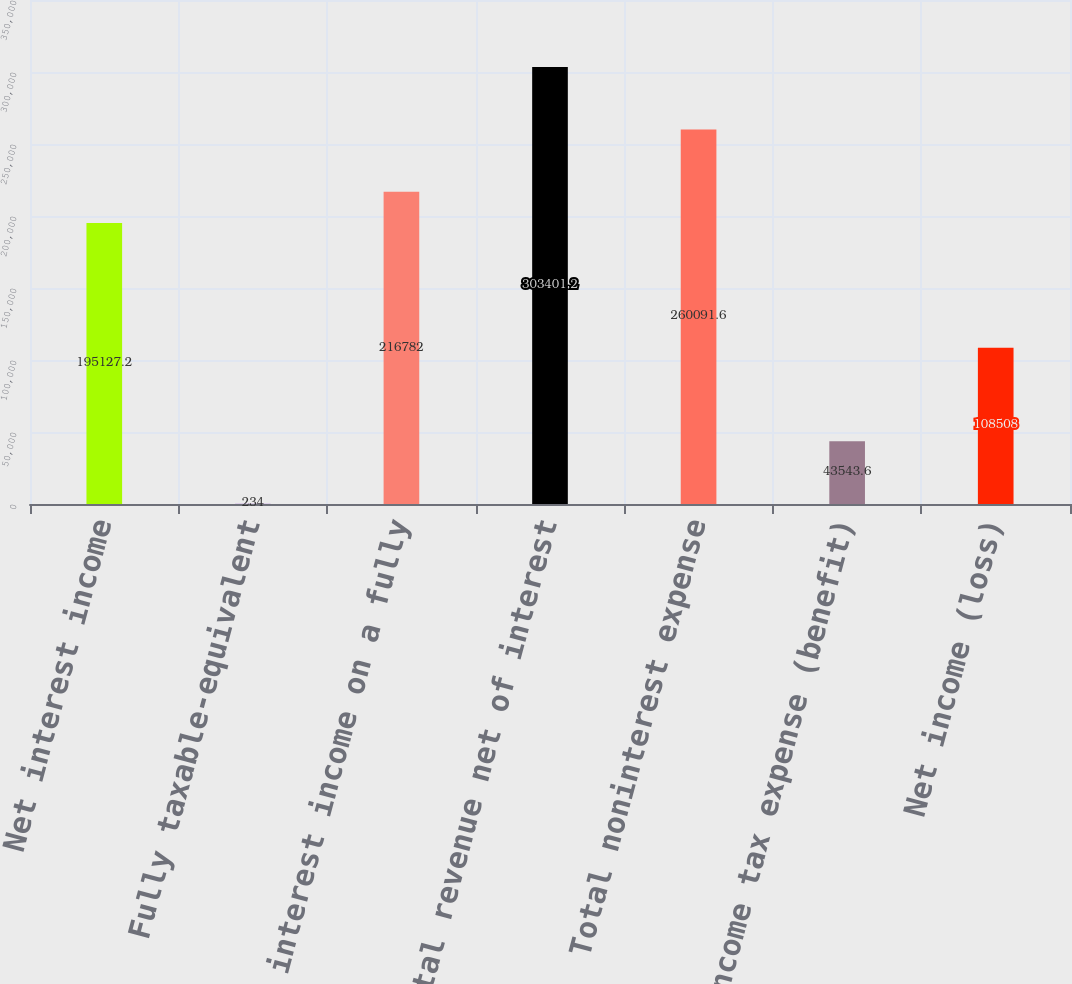Convert chart to OTSL. <chart><loc_0><loc_0><loc_500><loc_500><bar_chart><fcel>Net interest income<fcel>Fully taxable-equivalent<fcel>Net interest income on a fully<fcel>Total revenue net of interest<fcel>Total noninterest expense<fcel>Income tax expense (benefit)<fcel>Net income (loss)<nl><fcel>195127<fcel>234<fcel>216782<fcel>303401<fcel>260092<fcel>43543.6<fcel>108508<nl></chart> 